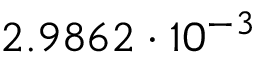Convert formula to latex. <formula><loc_0><loc_0><loc_500><loc_500>2 . 9 8 6 2 \cdot 1 0 ^ { - 3 }</formula> 